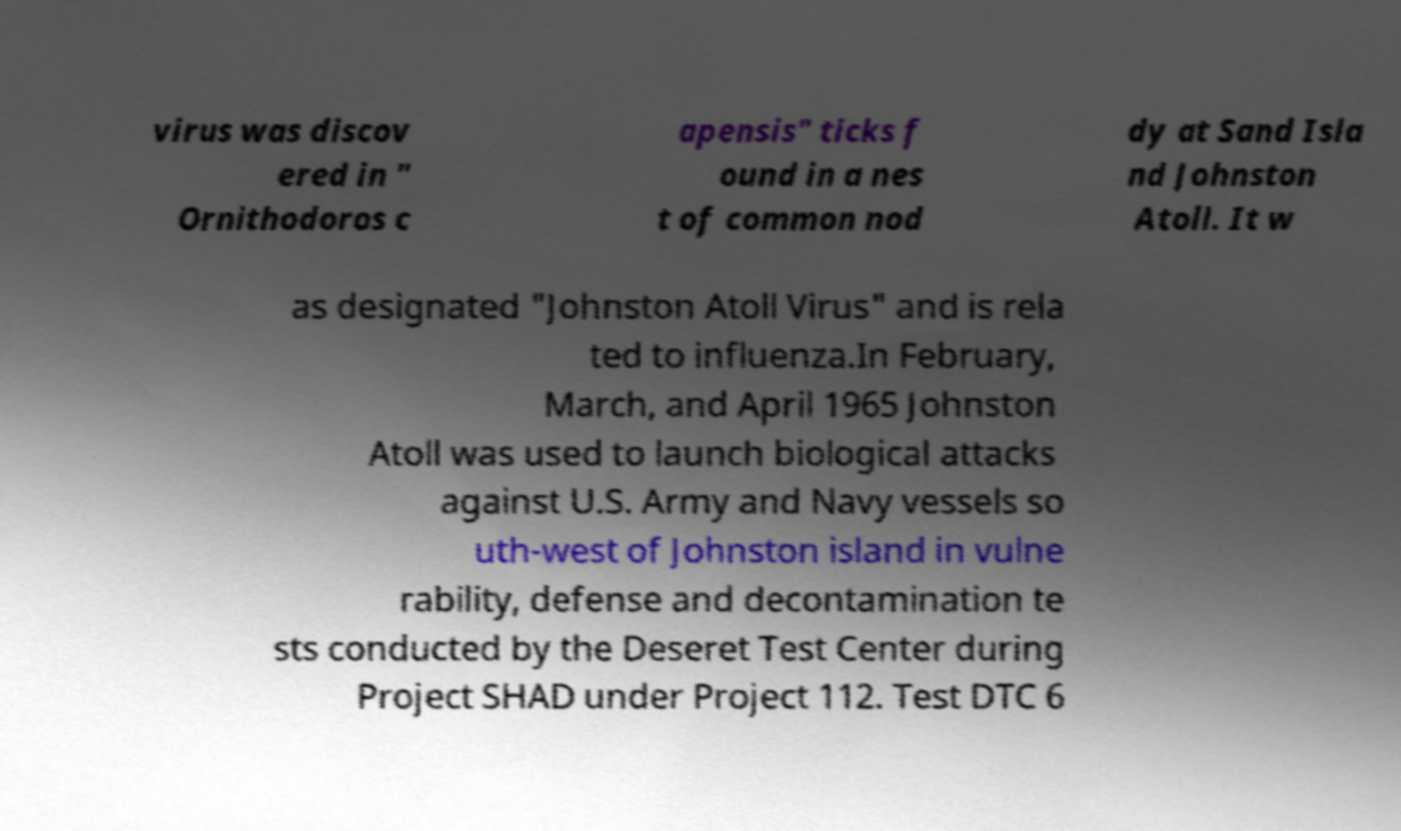Can you read and provide the text displayed in the image?This photo seems to have some interesting text. Can you extract and type it out for me? virus was discov ered in " Ornithodoros c apensis" ticks f ound in a nes t of common nod dy at Sand Isla nd Johnston Atoll. It w as designated "Johnston Atoll Virus" and is rela ted to influenza.In February, March, and April 1965 Johnston Atoll was used to launch biological attacks against U.S. Army and Navy vessels so uth-west of Johnston island in vulne rability, defense and decontamination te sts conducted by the Deseret Test Center during Project SHAD under Project 112. Test DTC 6 